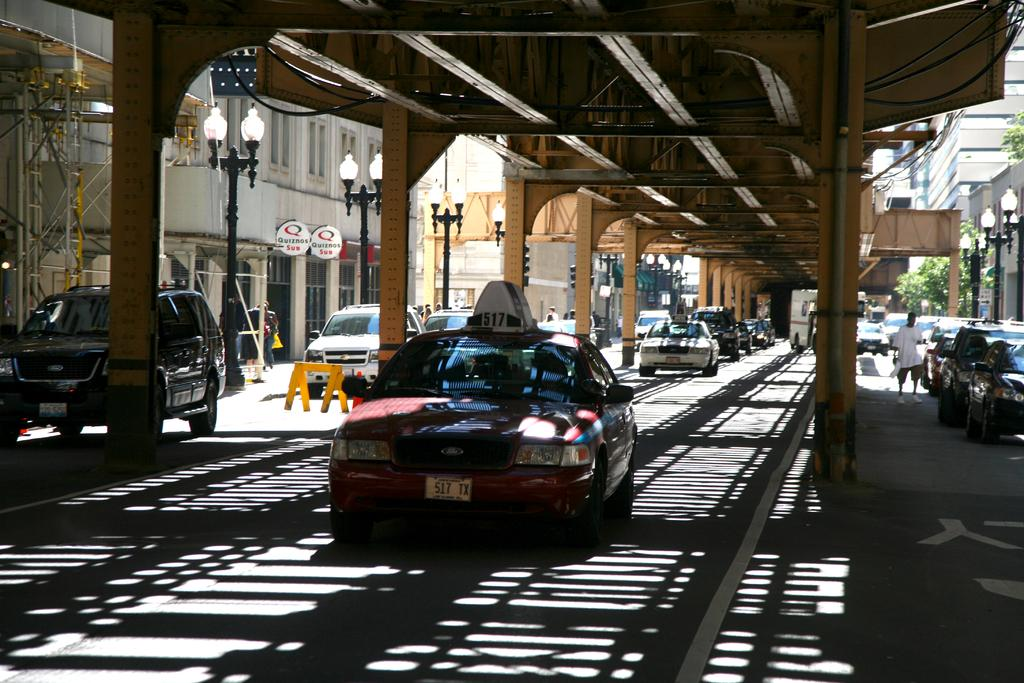What is the main subject in the foreground of the image? There is a car in the foreground of the image. Can you describe the people in the image? There are people in the image. What other types of vehicles can be seen in the image? There are vehicles in the image. What structures are present in the image? There are buildings in the image. What are the poles used for in the image? The poles are likely used for supporting electrical wires or other infrastructure. What can be seen in the background of the image? The sky is visible in the background of the image. What type of setting does the image appear to depict? The image appears to depict a subway setting. What type of cakes are being served on the plane in the image? There is no plane present in the image, and therefore no cakes being served. 